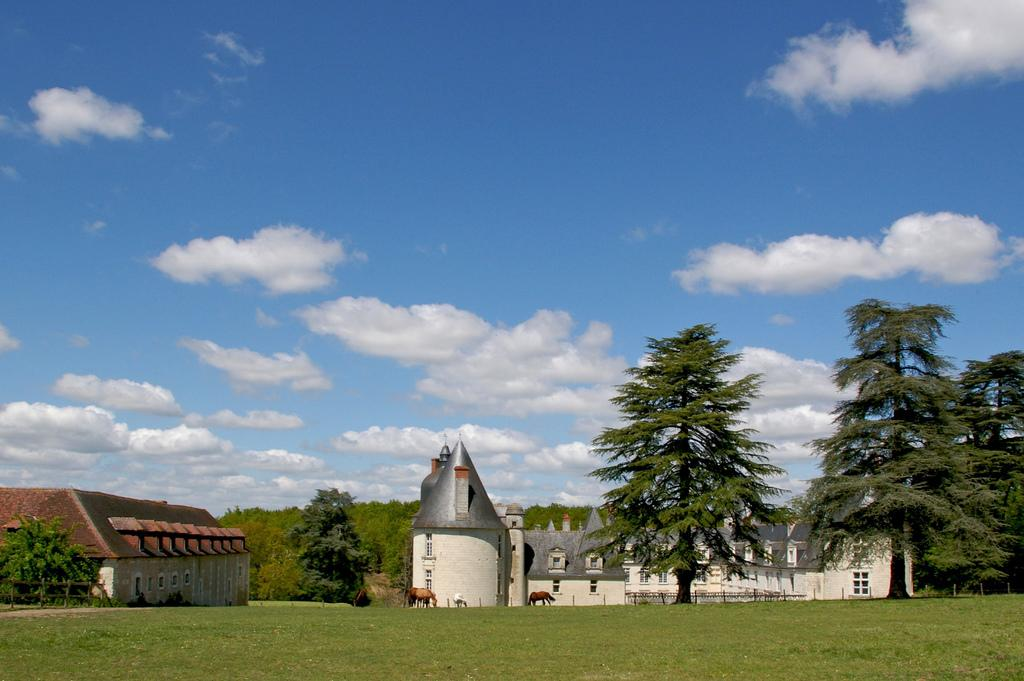What type of environment is depicted in the image? The image shows a grassland. What features are present on the grassland? There are animals and a fence on the grassland. What can be seen in the background of the image? There are trees and buildings in the background. What is visible at the top of the image? The sky is visible at the top of the image. What can be observed in the sky? There are clouds in the sky. What time is the clock showing in the image? There is no clock present in the image. What type of show is being performed by the animals in the image? There is no show being performed by the animals in the image; they are simply grazing on the grassland. 